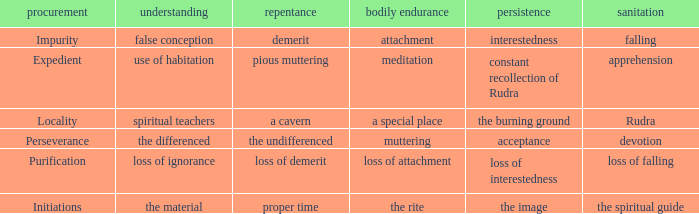 what's the permanence of the body where purity is rudra A special place. Could you parse the entire table? {'header': ['procurement', 'understanding', 'repentance', 'bodily endurance', 'persistence', 'sanitation'], 'rows': [['Impurity', 'false conception', 'demerit', 'attachment', 'interestedness', 'falling'], ['Expedient', 'use of habitation', 'pious muttering', 'meditation', 'constant recollection of Rudra', 'apprehension'], ['Locality', 'spiritual teachers', 'a cavern', 'a special place', 'the burning ground', 'Rudra'], ['Perseverance', 'the differenced', 'the undifferenced', 'muttering', 'acceptance', 'devotion'], ['Purification', 'loss of ignorance', 'loss of demerit', 'loss of attachment', 'loss of interestedness', 'loss of falling'], ['Initiations', 'the material', 'proper time', 'the rite', 'the image', 'the spiritual guide']]} 